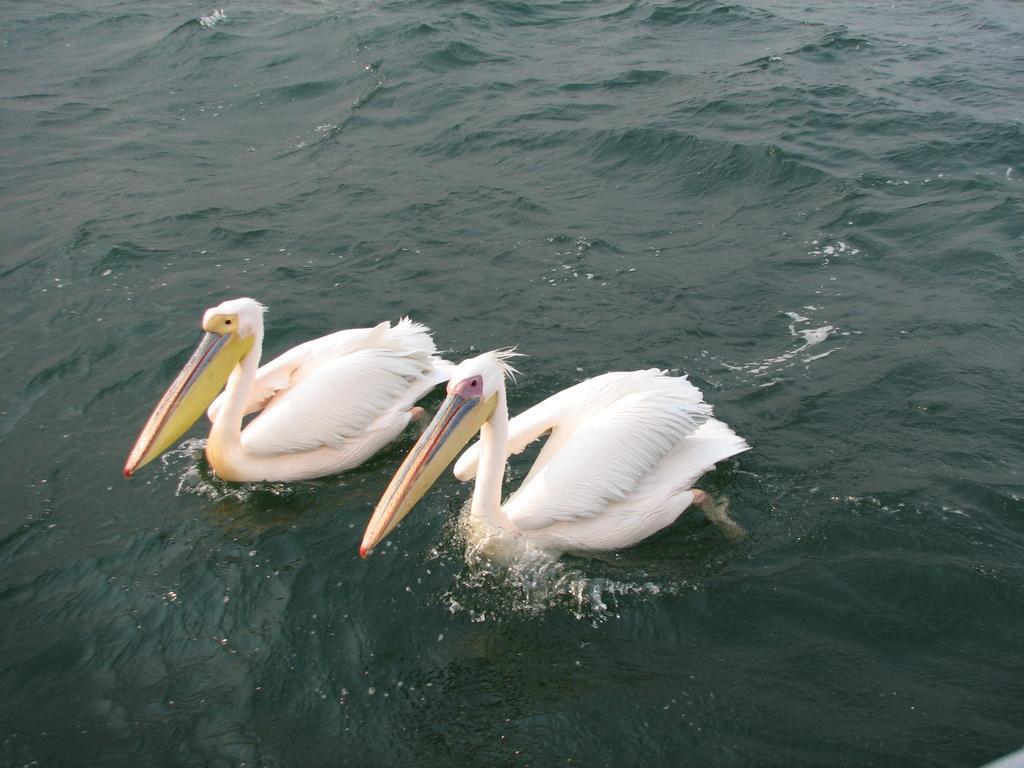In one or two sentences, can you explain what this image depicts? In this picture, we see the white pelicans are swimming in the water. These pelicans have long yellow color beaks. In the background, we see water and this water might be in the lake. 